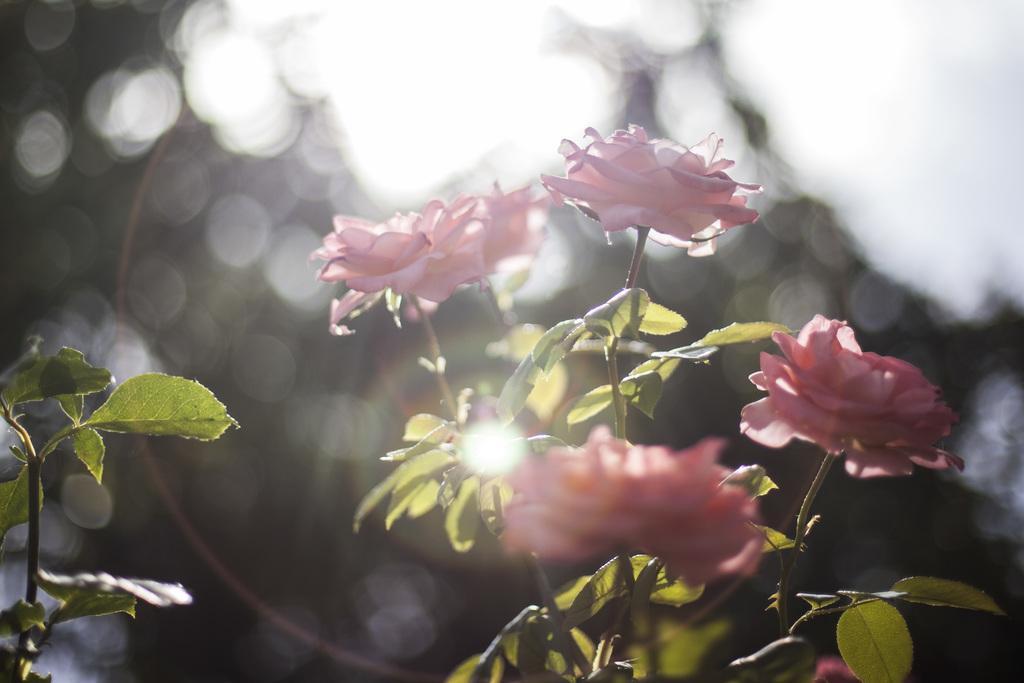Can you describe this image briefly? In this picture we can see few flowers and plants, and also we can see blurry background. 